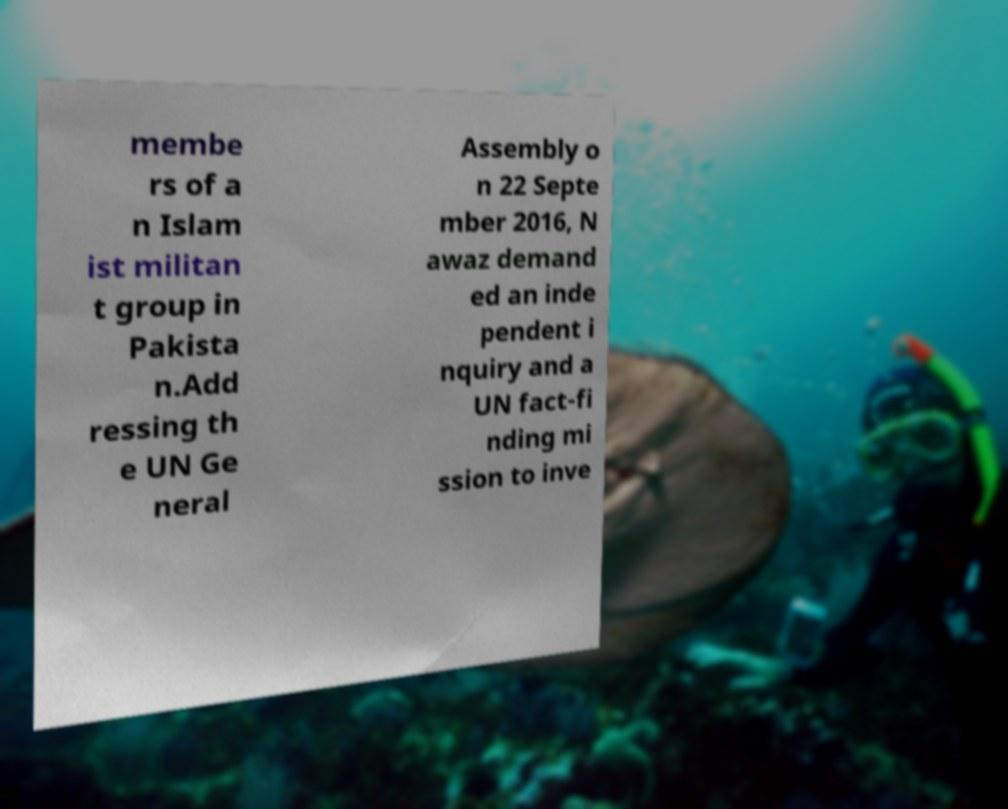Could you extract and type out the text from this image? membe rs of a n Islam ist militan t group in Pakista n.Add ressing th e UN Ge neral Assembly o n 22 Septe mber 2016, N awaz demand ed an inde pendent i nquiry and a UN fact-fi nding mi ssion to inve 